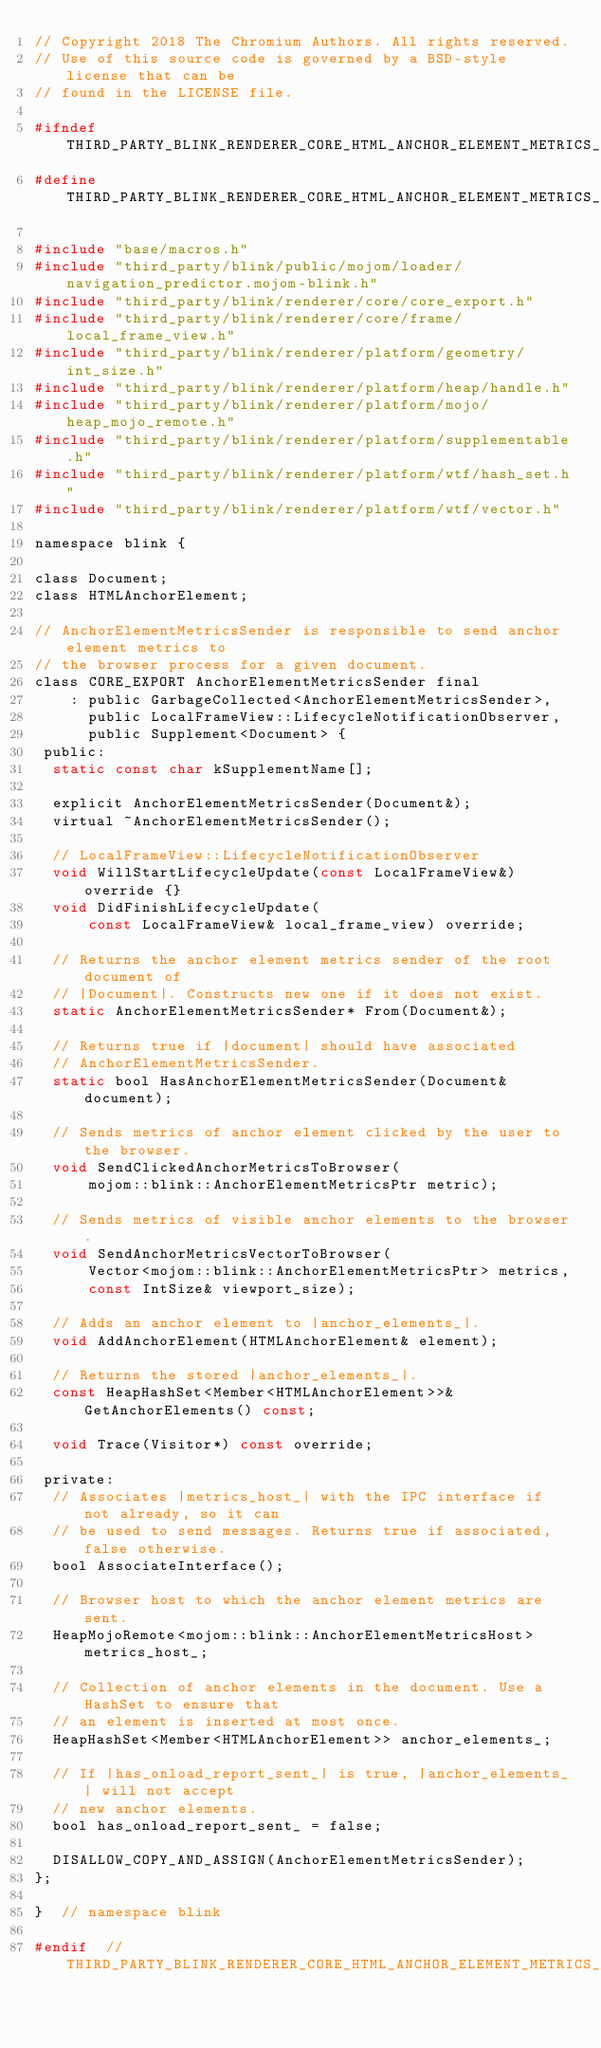<code> <loc_0><loc_0><loc_500><loc_500><_C_>// Copyright 2018 The Chromium Authors. All rights reserved.
// Use of this source code is governed by a BSD-style license that can be
// found in the LICENSE file.

#ifndef THIRD_PARTY_BLINK_RENDERER_CORE_HTML_ANCHOR_ELEMENT_METRICS_SENDER_H_
#define THIRD_PARTY_BLINK_RENDERER_CORE_HTML_ANCHOR_ELEMENT_METRICS_SENDER_H_

#include "base/macros.h"
#include "third_party/blink/public/mojom/loader/navigation_predictor.mojom-blink.h"
#include "third_party/blink/renderer/core/core_export.h"
#include "third_party/blink/renderer/core/frame/local_frame_view.h"
#include "third_party/blink/renderer/platform/geometry/int_size.h"
#include "third_party/blink/renderer/platform/heap/handle.h"
#include "third_party/blink/renderer/platform/mojo/heap_mojo_remote.h"
#include "third_party/blink/renderer/platform/supplementable.h"
#include "third_party/blink/renderer/platform/wtf/hash_set.h"
#include "third_party/blink/renderer/platform/wtf/vector.h"

namespace blink {

class Document;
class HTMLAnchorElement;

// AnchorElementMetricsSender is responsible to send anchor element metrics to
// the browser process for a given document.
class CORE_EXPORT AnchorElementMetricsSender final
    : public GarbageCollected<AnchorElementMetricsSender>,
      public LocalFrameView::LifecycleNotificationObserver,
      public Supplement<Document> {
 public:
  static const char kSupplementName[];

  explicit AnchorElementMetricsSender(Document&);
  virtual ~AnchorElementMetricsSender();

  // LocalFrameView::LifecycleNotificationObserver
  void WillStartLifecycleUpdate(const LocalFrameView&) override {}
  void DidFinishLifecycleUpdate(
      const LocalFrameView& local_frame_view) override;

  // Returns the anchor element metrics sender of the root document of
  // |Document|. Constructs new one if it does not exist.
  static AnchorElementMetricsSender* From(Document&);

  // Returns true if |document| should have associated
  // AnchorElementMetricsSender.
  static bool HasAnchorElementMetricsSender(Document& document);

  // Sends metrics of anchor element clicked by the user to the browser.
  void SendClickedAnchorMetricsToBrowser(
      mojom::blink::AnchorElementMetricsPtr metric);

  // Sends metrics of visible anchor elements to the browser.
  void SendAnchorMetricsVectorToBrowser(
      Vector<mojom::blink::AnchorElementMetricsPtr> metrics,
      const IntSize& viewport_size);

  // Adds an anchor element to |anchor_elements_|.
  void AddAnchorElement(HTMLAnchorElement& element);

  // Returns the stored |anchor_elements_|.
  const HeapHashSet<Member<HTMLAnchorElement>>& GetAnchorElements() const;

  void Trace(Visitor*) const override;

 private:
  // Associates |metrics_host_| with the IPC interface if not already, so it can
  // be used to send messages. Returns true if associated, false otherwise.
  bool AssociateInterface();

  // Browser host to which the anchor element metrics are sent.
  HeapMojoRemote<mojom::blink::AnchorElementMetricsHost> metrics_host_;

  // Collection of anchor elements in the document. Use a HashSet to ensure that
  // an element is inserted at most once.
  HeapHashSet<Member<HTMLAnchorElement>> anchor_elements_;

  // If |has_onload_report_sent_| is true, |anchor_elements_| will not accept
  // new anchor elements.
  bool has_onload_report_sent_ = false;

  DISALLOW_COPY_AND_ASSIGN(AnchorElementMetricsSender);
};

}  // namespace blink

#endif  // THIRD_PARTY_BLINK_RENDERER_CORE_HTML_ANCHOR_ELEMENT_METRICS_SENDER_H_
</code> 